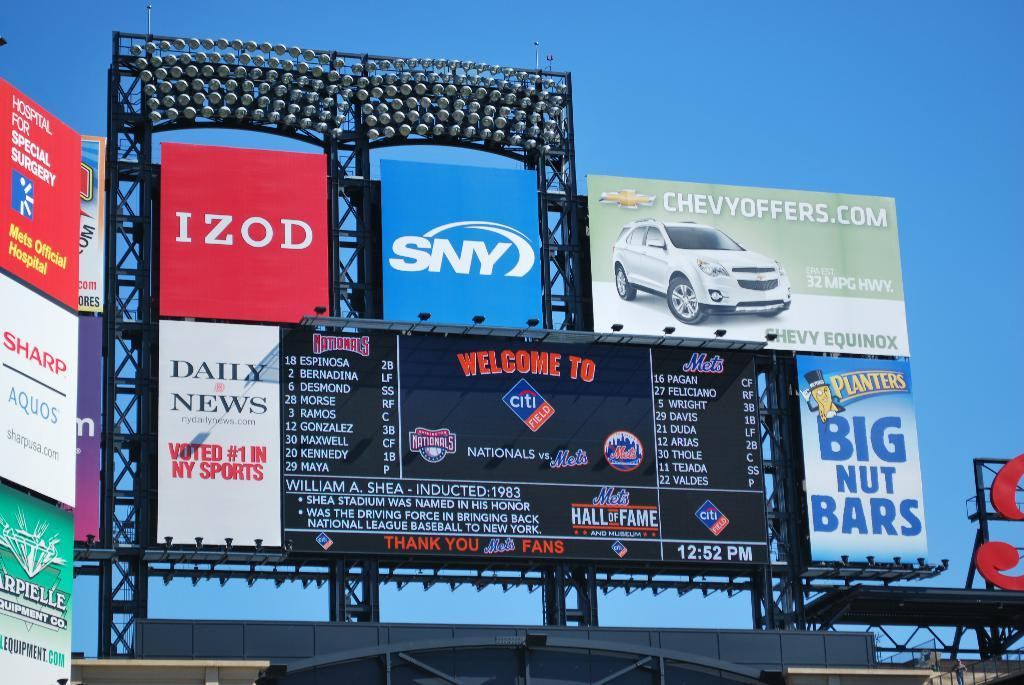<image>
Create a compact narrative representing the image presented. Billboard advertisements including IZOD and SNY on a clear blue sky background. 